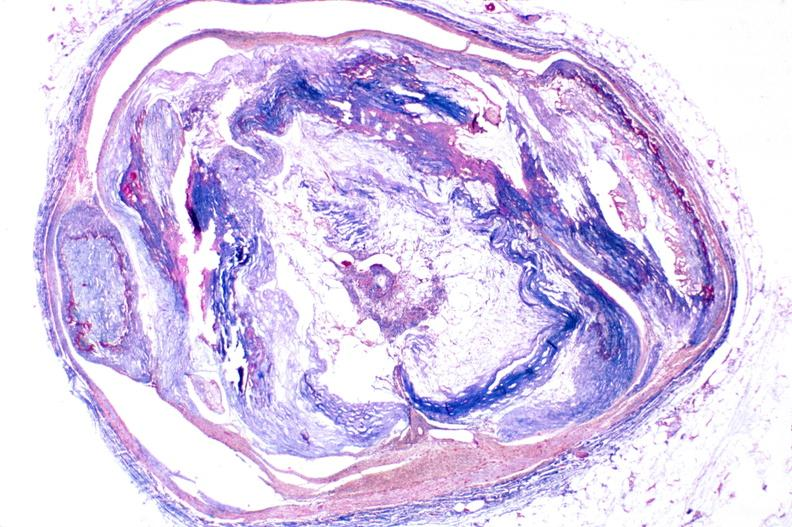does leiomyosarcoma show atherosclerosis, right coronary artery?
Answer the question using a single word or phrase. No 